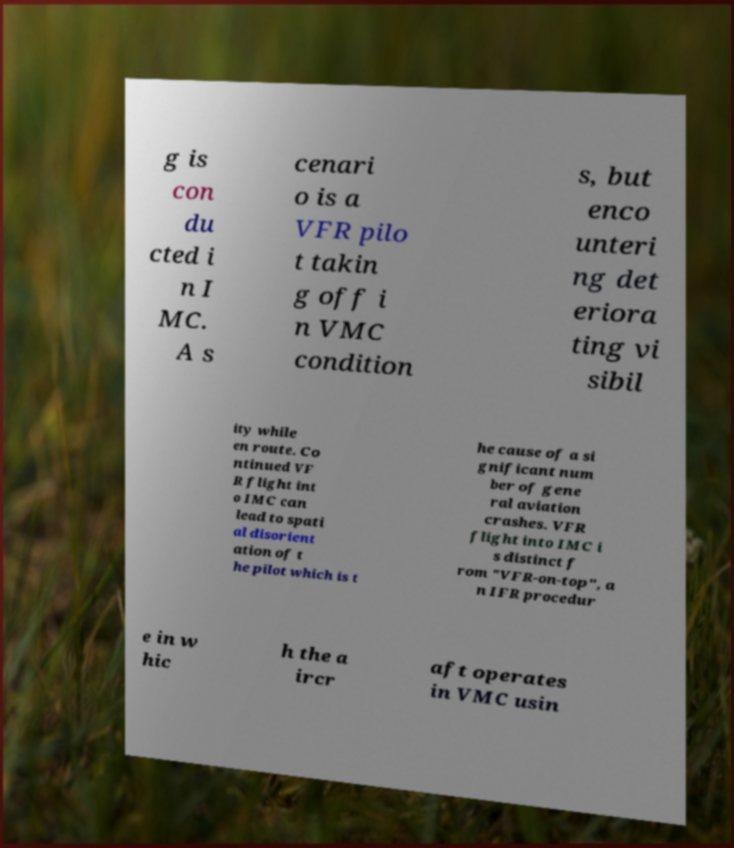For documentation purposes, I need the text within this image transcribed. Could you provide that? g is con du cted i n I MC. A s cenari o is a VFR pilo t takin g off i n VMC condition s, but enco unteri ng det eriora ting vi sibil ity while en route. Co ntinued VF R flight int o IMC can lead to spati al disorient ation of t he pilot which is t he cause of a si gnificant num ber of gene ral aviation crashes. VFR flight into IMC i s distinct f rom "VFR-on-top", a n IFR procedur e in w hic h the a ircr aft operates in VMC usin 